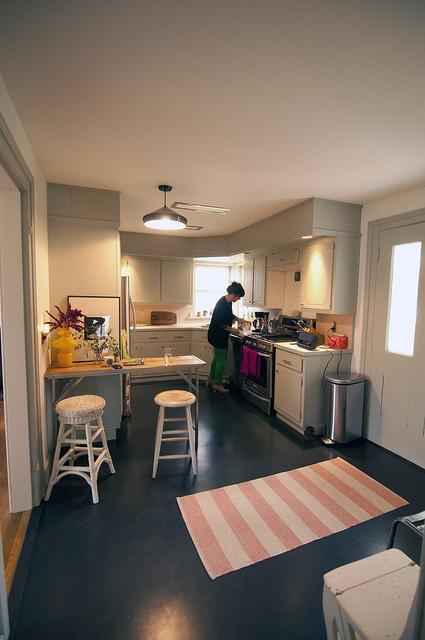How many white bar stools?
Give a very brief answer. 2. How many chairs are visible?
Give a very brief answer. 2. How many elephants have tusks?
Give a very brief answer. 0. 